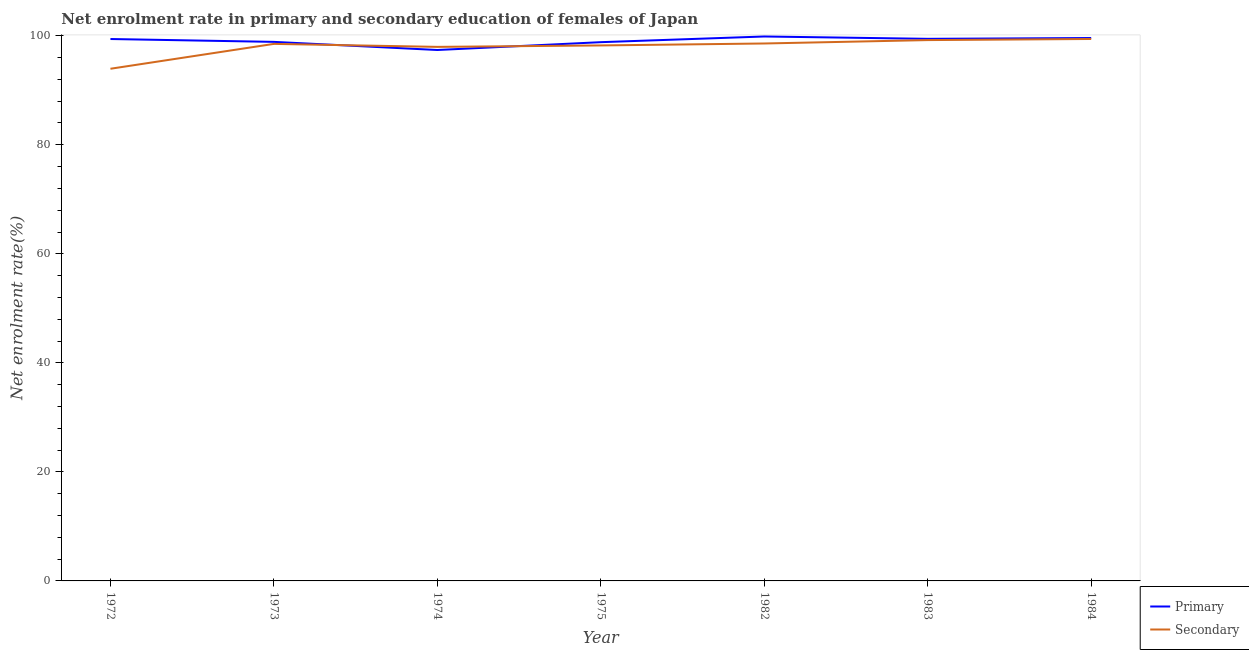How many different coloured lines are there?
Ensure brevity in your answer.  2. What is the enrollment rate in secondary education in 1983?
Your response must be concise. 99.21. Across all years, what is the maximum enrollment rate in primary education?
Your answer should be compact. 99.87. Across all years, what is the minimum enrollment rate in primary education?
Give a very brief answer. 97.39. In which year was the enrollment rate in secondary education maximum?
Provide a succinct answer. 1984. In which year was the enrollment rate in primary education minimum?
Keep it short and to the point. 1974. What is the total enrollment rate in secondary education in the graph?
Your response must be concise. 685.85. What is the difference between the enrollment rate in primary education in 1972 and that in 1975?
Your answer should be compact. 0.58. What is the difference between the enrollment rate in secondary education in 1972 and the enrollment rate in primary education in 1984?
Provide a short and direct response. -5.64. What is the average enrollment rate in secondary education per year?
Your answer should be compact. 97.98. In the year 1972, what is the difference between the enrollment rate in secondary education and enrollment rate in primary education?
Offer a very short reply. -5.45. In how many years, is the enrollment rate in primary education greater than 16 %?
Ensure brevity in your answer.  7. What is the ratio of the enrollment rate in primary education in 1973 to that in 1983?
Your response must be concise. 0.99. Is the difference between the enrollment rate in secondary education in 1982 and 1983 greater than the difference between the enrollment rate in primary education in 1982 and 1983?
Provide a short and direct response. No. What is the difference between the highest and the second highest enrollment rate in primary education?
Provide a short and direct response. 0.28. What is the difference between the highest and the lowest enrollment rate in secondary education?
Make the answer very short. 5.46. In how many years, is the enrollment rate in secondary education greater than the average enrollment rate in secondary education taken over all years?
Give a very brief answer. 5. Is the sum of the enrollment rate in primary education in 1973 and 1983 greater than the maximum enrollment rate in secondary education across all years?
Your answer should be compact. Yes. Does the enrollment rate in primary education monotonically increase over the years?
Provide a succinct answer. No. Is the enrollment rate in secondary education strictly greater than the enrollment rate in primary education over the years?
Keep it short and to the point. No. Is the enrollment rate in secondary education strictly less than the enrollment rate in primary education over the years?
Offer a very short reply. No. How many lines are there?
Your answer should be compact. 2. Where does the legend appear in the graph?
Your answer should be compact. Bottom right. What is the title of the graph?
Offer a terse response. Net enrolment rate in primary and secondary education of females of Japan. What is the label or title of the Y-axis?
Your answer should be compact. Net enrolment rate(%). What is the Net enrolment rate(%) in Primary in 1972?
Offer a very short reply. 99.4. What is the Net enrolment rate(%) of Secondary in 1972?
Your answer should be compact. 93.95. What is the Net enrolment rate(%) of Primary in 1973?
Give a very brief answer. 98.88. What is the Net enrolment rate(%) in Secondary in 1973?
Keep it short and to the point. 98.51. What is the Net enrolment rate(%) in Primary in 1974?
Make the answer very short. 97.39. What is the Net enrolment rate(%) of Secondary in 1974?
Provide a short and direct response. 97.96. What is the Net enrolment rate(%) of Primary in 1975?
Offer a very short reply. 98.82. What is the Net enrolment rate(%) in Secondary in 1975?
Offer a very short reply. 98.23. What is the Net enrolment rate(%) of Primary in 1982?
Provide a short and direct response. 99.87. What is the Net enrolment rate(%) of Secondary in 1982?
Your answer should be compact. 98.59. What is the Net enrolment rate(%) in Primary in 1983?
Your response must be concise. 99.44. What is the Net enrolment rate(%) in Secondary in 1983?
Ensure brevity in your answer.  99.21. What is the Net enrolment rate(%) in Primary in 1984?
Ensure brevity in your answer.  99.59. What is the Net enrolment rate(%) of Secondary in 1984?
Offer a terse response. 99.41. Across all years, what is the maximum Net enrolment rate(%) of Primary?
Offer a terse response. 99.87. Across all years, what is the maximum Net enrolment rate(%) in Secondary?
Make the answer very short. 99.41. Across all years, what is the minimum Net enrolment rate(%) of Primary?
Offer a terse response. 97.39. Across all years, what is the minimum Net enrolment rate(%) of Secondary?
Your answer should be compact. 93.95. What is the total Net enrolment rate(%) of Primary in the graph?
Make the answer very short. 693.39. What is the total Net enrolment rate(%) of Secondary in the graph?
Ensure brevity in your answer.  685.85. What is the difference between the Net enrolment rate(%) in Primary in 1972 and that in 1973?
Your answer should be very brief. 0.52. What is the difference between the Net enrolment rate(%) of Secondary in 1972 and that in 1973?
Provide a short and direct response. -4.56. What is the difference between the Net enrolment rate(%) in Primary in 1972 and that in 1974?
Give a very brief answer. 2.01. What is the difference between the Net enrolment rate(%) in Secondary in 1972 and that in 1974?
Provide a short and direct response. -4.02. What is the difference between the Net enrolment rate(%) of Primary in 1972 and that in 1975?
Provide a succinct answer. 0.58. What is the difference between the Net enrolment rate(%) in Secondary in 1972 and that in 1975?
Your response must be concise. -4.28. What is the difference between the Net enrolment rate(%) in Primary in 1972 and that in 1982?
Offer a terse response. -0.46. What is the difference between the Net enrolment rate(%) of Secondary in 1972 and that in 1982?
Ensure brevity in your answer.  -4.64. What is the difference between the Net enrolment rate(%) in Primary in 1972 and that in 1983?
Your response must be concise. -0.04. What is the difference between the Net enrolment rate(%) in Secondary in 1972 and that in 1983?
Provide a succinct answer. -5.26. What is the difference between the Net enrolment rate(%) of Primary in 1972 and that in 1984?
Give a very brief answer. -0.19. What is the difference between the Net enrolment rate(%) in Secondary in 1972 and that in 1984?
Give a very brief answer. -5.46. What is the difference between the Net enrolment rate(%) in Primary in 1973 and that in 1974?
Give a very brief answer. 1.49. What is the difference between the Net enrolment rate(%) in Secondary in 1973 and that in 1974?
Your answer should be compact. 0.55. What is the difference between the Net enrolment rate(%) of Primary in 1973 and that in 1975?
Your answer should be compact. 0.06. What is the difference between the Net enrolment rate(%) in Secondary in 1973 and that in 1975?
Your answer should be very brief. 0.28. What is the difference between the Net enrolment rate(%) in Primary in 1973 and that in 1982?
Keep it short and to the point. -0.99. What is the difference between the Net enrolment rate(%) in Secondary in 1973 and that in 1982?
Offer a terse response. -0.08. What is the difference between the Net enrolment rate(%) in Primary in 1973 and that in 1983?
Your answer should be very brief. -0.56. What is the difference between the Net enrolment rate(%) in Secondary in 1973 and that in 1983?
Provide a short and direct response. -0.7. What is the difference between the Net enrolment rate(%) of Primary in 1973 and that in 1984?
Make the answer very short. -0.71. What is the difference between the Net enrolment rate(%) in Secondary in 1973 and that in 1984?
Your response must be concise. -0.9. What is the difference between the Net enrolment rate(%) of Primary in 1974 and that in 1975?
Your response must be concise. -1.43. What is the difference between the Net enrolment rate(%) of Secondary in 1974 and that in 1975?
Ensure brevity in your answer.  -0.26. What is the difference between the Net enrolment rate(%) of Primary in 1974 and that in 1982?
Provide a short and direct response. -2.48. What is the difference between the Net enrolment rate(%) of Secondary in 1974 and that in 1982?
Ensure brevity in your answer.  -0.62. What is the difference between the Net enrolment rate(%) of Primary in 1974 and that in 1983?
Keep it short and to the point. -2.05. What is the difference between the Net enrolment rate(%) of Secondary in 1974 and that in 1983?
Make the answer very short. -1.24. What is the difference between the Net enrolment rate(%) in Primary in 1974 and that in 1984?
Ensure brevity in your answer.  -2.2. What is the difference between the Net enrolment rate(%) of Secondary in 1974 and that in 1984?
Provide a succinct answer. -1.45. What is the difference between the Net enrolment rate(%) of Primary in 1975 and that in 1982?
Make the answer very short. -1.04. What is the difference between the Net enrolment rate(%) in Secondary in 1975 and that in 1982?
Your answer should be compact. -0.36. What is the difference between the Net enrolment rate(%) of Primary in 1975 and that in 1983?
Give a very brief answer. -0.62. What is the difference between the Net enrolment rate(%) in Secondary in 1975 and that in 1983?
Give a very brief answer. -0.98. What is the difference between the Net enrolment rate(%) in Primary in 1975 and that in 1984?
Give a very brief answer. -0.76. What is the difference between the Net enrolment rate(%) in Secondary in 1975 and that in 1984?
Your response must be concise. -1.19. What is the difference between the Net enrolment rate(%) in Primary in 1982 and that in 1983?
Your response must be concise. 0.43. What is the difference between the Net enrolment rate(%) in Secondary in 1982 and that in 1983?
Give a very brief answer. -0.62. What is the difference between the Net enrolment rate(%) in Primary in 1982 and that in 1984?
Offer a very short reply. 0.28. What is the difference between the Net enrolment rate(%) of Secondary in 1982 and that in 1984?
Your answer should be compact. -0.83. What is the difference between the Net enrolment rate(%) of Primary in 1983 and that in 1984?
Your answer should be very brief. -0.15. What is the difference between the Net enrolment rate(%) of Secondary in 1983 and that in 1984?
Your answer should be compact. -0.2. What is the difference between the Net enrolment rate(%) in Primary in 1972 and the Net enrolment rate(%) in Secondary in 1973?
Keep it short and to the point. 0.89. What is the difference between the Net enrolment rate(%) of Primary in 1972 and the Net enrolment rate(%) of Secondary in 1974?
Give a very brief answer. 1.44. What is the difference between the Net enrolment rate(%) in Primary in 1972 and the Net enrolment rate(%) in Secondary in 1975?
Provide a succinct answer. 1.18. What is the difference between the Net enrolment rate(%) of Primary in 1972 and the Net enrolment rate(%) of Secondary in 1982?
Offer a terse response. 0.82. What is the difference between the Net enrolment rate(%) of Primary in 1972 and the Net enrolment rate(%) of Secondary in 1983?
Ensure brevity in your answer.  0.2. What is the difference between the Net enrolment rate(%) of Primary in 1972 and the Net enrolment rate(%) of Secondary in 1984?
Provide a succinct answer. -0.01. What is the difference between the Net enrolment rate(%) in Primary in 1973 and the Net enrolment rate(%) in Secondary in 1974?
Make the answer very short. 0.92. What is the difference between the Net enrolment rate(%) of Primary in 1973 and the Net enrolment rate(%) of Secondary in 1975?
Offer a very short reply. 0.65. What is the difference between the Net enrolment rate(%) in Primary in 1973 and the Net enrolment rate(%) in Secondary in 1982?
Ensure brevity in your answer.  0.29. What is the difference between the Net enrolment rate(%) in Primary in 1973 and the Net enrolment rate(%) in Secondary in 1983?
Provide a succinct answer. -0.33. What is the difference between the Net enrolment rate(%) in Primary in 1973 and the Net enrolment rate(%) in Secondary in 1984?
Your answer should be compact. -0.53. What is the difference between the Net enrolment rate(%) in Primary in 1974 and the Net enrolment rate(%) in Secondary in 1975?
Your answer should be compact. -0.83. What is the difference between the Net enrolment rate(%) of Primary in 1974 and the Net enrolment rate(%) of Secondary in 1982?
Your answer should be compact. -1.2. What is the difference between the Net enrolment rate(%) of Primary in 1974 and the Net enrolment rate(%) of Secondary in 1983?
Your answer should be very brief. -1.82. What is the difference between the Net enrolment rate(%) in Primary in 1974 and the Net enrolment rate(%) in Secondary in 1984?
Your answer should be compact. -2.02. What is the difference between the Net enrolment rate(%) in Primary in 1975 and the Net enrolment rate(%) in Secondary in 1982?
Your answer should be compact. 0.24. What is the difference between the Net enrolment rate(%) of Primary in 1975 and the Net enrolment rate(%) of Secondary in 1983?
Your response must be concise. -0.38. What is the difference between the Net enrolment rate(%) in Primary in 1975 and the Net enrolment rate(%) in Secondary in 1984?
Keep it short and to the point. -0.59. What is the difference between the Net enrolment rate(%) in Primary in 1982 and the Net enrolment rate(%) in Secondary in 1983?
Give a very brief answer. 0.66. What is the difference between the Net enrolment rate(%) of Primary in 1982 and the Net enrolment rate(%) of Secondary in 1984?
Your answer should be very brief. 0.46. What is the difference between the Net enrolment rate(%) in Primary in 1983 and the Net enrolment rate(%) in Secondary in 1984?
Give a very brief answer. 0.03. What is the average Net enrolment rate(%) of Primary per year?
Your response must be concise. 99.06. What is the average Net enrolment rate(%) of Secondary per year?
Keep it short and to the point. 97.98. In the year 1972, what is the difference between the Net enrolment rate(%) of Primary and Net enrolment rate(%) of Secondary?
Give a very brief answer. 5.46. In the year 1973, what is the difference between the Net enrolment rate(%) in Primary and Net enrolment rate(%) in Secondary?
Offer a terse response. 0.37. In the year 1974, what is the difference between the Net enrolment rate(%) of Primary and Net enrolment rate(%) of Secondary?
Keep it short and to the point. -0.57. In the year 1975, what is the difference between the Net enrolment rate(%) in Primary and Net enrolment rate(%) in Secondary?
Ensure brevity in your answer.  0.6. In the year 1982, what is the difference between the Net enrolment rate(%) of Primary and Net enrolment rate(%) of Secondary?
Keep it short and to the point. 1.28. In the year 1983, what is the difference between the Net enrolment rate(%) in Primary and Net enrolment rate(%) in Secondary?
Keep it short and to the point. 0.23. In the year 1984, what is the difference between the Net enrolment rate(%) of Primary and Net enrolment rate(%) of Secondary?
Your response must be concise. 0.18. What is the ratio of the Net enrolment rate(%) in Secondary in 1972 to that in 1973?
Keep it short and to the point. 0.95. What is the ratio of the Net enrolment rate(%) in Primary in 1972 to that in 1974?
Offer a very short reply. 1.02. What is the ratio of the Net enrolment rate(%) in Primary in 1972 to that in 1975?
Keep it short and to the point. 1.01. What is the ratio of the Net enrolment rate(%) in Secondary in 1972 to that in 1975?
Keep it short and to the point. 0.96. What is the ratio of the Net enrolment rate(%) in Primary in 1972 to that in 1982?
Make the answer very short. 1. What is the ratio of the Net enrolment rate(%) of Secondary in 1972 to that in 1982?
Provide a short and direct response. 0.95. What is the ratio of the Net enrolment rate(%) in Secondary in 1972 to that in 1983?
Provide a short and direct response. 0.95. What is the ratio of the Net enrolment rate(%) of Primary in 1972 to that in 1984?
Provide a short and direct response. 1. What is the ratio of the Net enrolment rate(%) in Secondary in 1972 to that in 1984?
Give a very brief answer. 0.94. What is the ratio of the Net enrolment rate(%) of Primary in 1973 to that in 1974?
Your answer should be compact. 1.02. What is the ratio of the Net enrolment rate(%) in Secondary in 1973 to that in 1974?
Your answer should be compact. 1.01. What is the ratio of the Net enrolment rate(%) in Secondary in 1973 to that in 1975?
Your answer should be compact. 1. What is the ratio of the Net enrolment rate(%) in Primary in 1973 to that in 1982?
Keep it short and to the point. 0.99. What is the ratio of the Net enrolment rate(%) in Primary in 1973 to that in 1983?
Provide a succinct answer. 0.99. What is the ratio of the Net enrolment rate(%) in Secondary in 1973 to that in 1984?
Your response must be concise. 0.99. What is the ratio of the Net enrolment rate(%) in Primary in 1974 to that in 1975?
Provide a short and direct response. 0.99. What is the ratio of the Net enrolment rate(%) in Primary in 1974 to that in 1982?
Your response must be concise. 0.98. What is the ratio of the Net enrolment rate(%) of Primary in 1974 to that in 1983?
Provide a succinct answer. 0.98. What is the ratio of the Net enrolment rate(%) in Secondary in 1974 to that in 1983?
Offer a terse response. 0.99. What is the ratio of the Net enrolment rate(%) of Primary in 1974 to that in 1984?
Make the answer very short. 0.98. What is the ratio of the Net enrolment rate(%) of Secondary in 1974 to that in 1984?
Your response must be concise. 0.99. What is the ratio of the Net enrolment rate(%) in Primary in 1975 to that in 1982?
Make the answer very short. 0.99. What is the ratio of the Net enrolment rate(%) of Secondary in 1975 to that in 1982?
Your response must be concise. 1. What is the ratio of the Net enrolment rate(%) of Primary in 1975 to that in 1983?
Your answer should be very brief. 0.99. What is the ratio of the Net enrolment rate(%) of Primary in 1975 to that in 1984?
Your response must be concise. 0.99. What is the ratio of the Net enrolment rate(%) of Secondary in 1975 to that in 1984?
Keep it short and to the point. 0.99. What is the ratio of the Net enrolment rate(%) of Primary in 1982 to that in 1983?
Provide a short and direct response. 1. What is the ratio of the Net enrolment rate(%) of Primary in 1982 to that in 1984?
Keep it short and to the point. 1. What is the ratio of the Net enrolment rate(%) of Primary in 1983 to that in 1984?
Offer a terse response. 1. What is the ratio of the Net enrolment rate(%) in Secondary in 1983 to that in 1984?
Keep it short and to the point. 1. What is the difference between the highest and the second highest Net enrolment rate(%) in Primary?
Offer a terse response. 0.28. What is the difference between the highest and the second highest Net enrolment rate(%) in Secondary?
Offer a terse response. 0.2. What is the difference between the highest and the lowest Net enrolment rate(%) in Primary?
Offer a very short reply. 2.48. What is the difference between the highest and the lowest Net enrolment rate(%) of Secondary?
Your answer should be very brief. 5.46. 